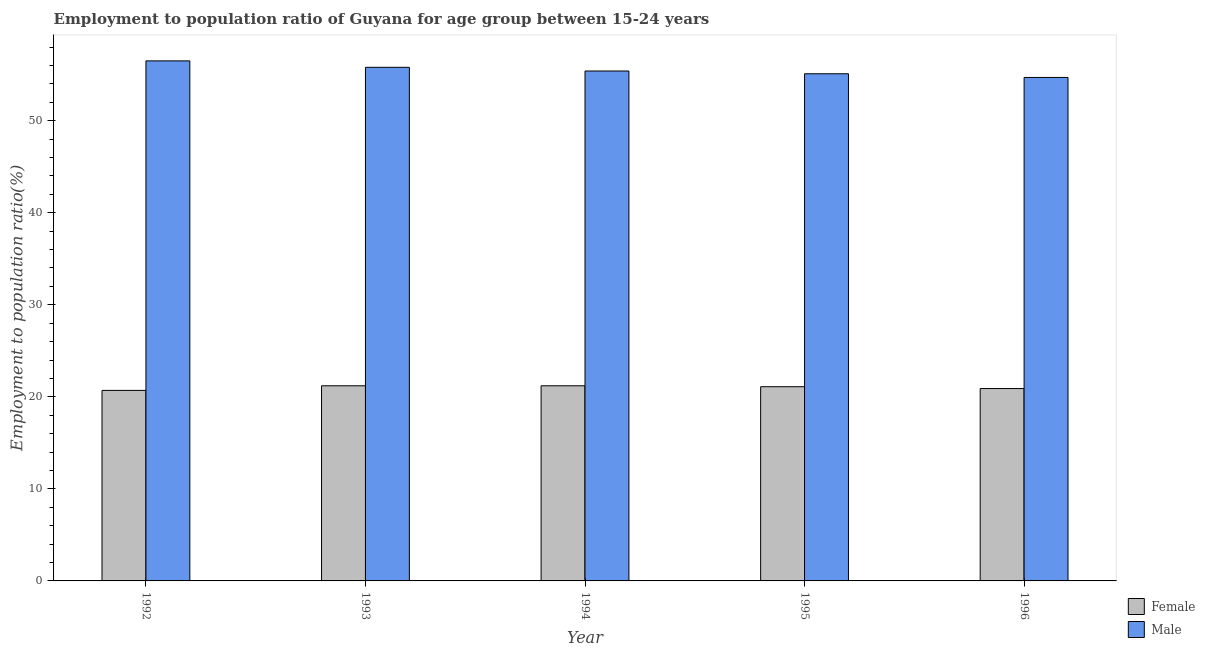How many groups of bars are there?
Your answer should be very brief. 5. Are the number of bars on each tick of the X-axis equal?
Ensure brevity in your answer.  Yes. How many bars are there on the 4th tick from the left?
Your answer should be compact. 2. What is the label of the 2nd group of bars from the left?
Offer a very short reply. 1993. In how many cases, is the number of bars for a given year not equal to the number of legend labels?
Provide a succinct answer. 0. What is the employment to population ratio(female) in 1996?
Your answer should be compact. 20.9. Across all years, what is the maximum employment to population ratio(male)?
Your response must be concise. 56.5. Across all years, what is the minimum employment to population ratio(male)?
Your answer should be compact. 54.7. What is the total employment to population ratio(female) in the graph?
Keep it short and to the point. 105.1. What is the difference between the employment to population ratio(male) in 1993 and that in 1995?
Your answer should be compact. 0.7. What is the difference between the employment to population ratio(female) in 1995 and the employment to population ratio(male) in 1992?
Your answer should be compact. 0.4. What is the average employment to population ratio(female) per year?
Your answer should be very brief. 21.02. In the year 1996, what is the difference between the employment to population ratio(female) and employment to population ratio(male)?
Make the answer very short. 0. In how many years, is the employment to population ratio(male) greater than 44 %?
Your response must be concise. 5. What is the ratio of the employment to population ratio(male) in 1992 to that in 1994?
Your response must be concise. 1.02. Is the difference between the employment to population ratio(female) in 1994 and 1996 greater than the difference between the employment to population ratio(male) in 1994 and 1996?
Make the answer very short. No. What is the difference between the highest and the second highest employment to population ratio(male)?
Your response must be concise. 0.7. What is the difference between the highest and the lowest employment to population ratio(male)?
Keep it short and to the point. 1.8. In how many years, is the employment to population ratio(female) greater than the average employment to population ratio(female) taken over all years?
Give a very brief answer. 3. What does the 1st bar from the right in 1992 represents?
Your answer should be compact. Male. How many bars are there?
Offer a terse response. 10. Does the graph contain grids?
Ensure brevity in your answer.  No. Where does the legend appear in the graph?
Your response must be concise. Bottom right. What is the title of the graph?
Make the answer very short. Employment to population ratio of Guyana for age group between 15-24 years. What is the label or title of the Y-axis?
Offer a terse response. Employment to population ratio(%). What is the Employment to population ratio(%) of Female in 1992?
Keep it short and to the point. 20.7. What is the Employment to population ratio(%) of Male in 1992?
Ensure brevity in your answer.  56.5. What is the Employment to population ratio(%) in Female in 1993?
Keep it short and to the point. 21.2. What is the Employment to population ratio(%) of Male in 1993?
Ensure brevity in your answer.  55.8. What is the Employment to population ratio(%) in Female in 1994?
Keep it short and to the point. 21.2. What is the Employment to population ratio(%) in Male in 1994?
Your answer should be very brief. 55.4. What is the Employment to population ratio(%) of Female in 1995?
Your answer should be very brief. 21.1. What is the Employment to population ratio(%) in Male in 1995?
Offer a terse response. 55.1. What is the Employment to population ratio(%) in Female in 1996?
Ensure brevity in your answer.  20.9. What is the Employment to population ratio(%) of Male in 1996?
Your answer should be compact. 54.7. Across all years, what is the maximum Employment to population ratio(%) of Female?
Your response must be concise. 21.2. Across all years, what is the maximum Employment to population ratio(%) in Male?
Give a very brief answer. 56.5. Across all years, what is the minimum Employment to population ratio(%) in Female?
Your answer should be very brief. 20.7. Across all years, what is the minimum Employment to population ratio(%) of Male?
Offer a very short reply. 54.7. What is the total Employment to population ratio(%) in Female in the graph?
Give a very brief answer. 105.1. What is the total Employment to population ratio(%) of Male in the graph?
Provide a succinct answer. 277.5. What is the difference between the Employment to population ratio(%) of Male in 1992 and that in 1995?
Make the answer very short. 1.4. What is the difference between the Employment to population ratio(%) of Male in 1992 and that in 1996?
Your answer should be compact. 1.8. What is the difference between the Employment to population ratio(%) in Female in 1993 and that in 1996?
Ensure brevity in your answer.  0.3. What is the difference between the Employment to population ratio(%) of Female in 1994 and that in 1995?
Give a very brief answer. 0.1. What is the difference between the Employment to population ratio(%) in Male in 1994 and that in 1995?
Your answer should be very brief. 0.3. What is the difference between the Employment to population ratio(%) in Female in 1995 and that in 1996?
Make the answer very short. 0.2. What is the difference between the Employment to population ratio(%) of Female in 1992 and the Employment to population ratio(%) of Male in 1993?
Give a very brief answer. -35.1. What is the difference between the Employment to population ratio(%) of Female in 1992 and the Employment to population ratio(%) of Male in 1994?
Your answer should be compact. -34.7. What is the difference between the Employment to population ratio(%) in Female in 1992 and the Employment to population ratio(%) in Male in 1995?
Your answer should be compact. -34.4. What is the difference between the Employment to population ratio(%) of Female in 1992 and the Employment to population ratio(%) of Male in 1996?
Keep it short and to the point. -34. What is the difference between the Employment to population ratio(%) in Female in 1993 and the Employment to population ratio(%) in Male in 1994?
Give a very brief answer. -34.2. What is the difference between the Employment to population ratio(%) in Female in 1993 and the Employment to population ratio(%) in Male in 1995?
Your response must be concise. -33.9. What is the difference between the Employment to population ratio(%) of Female in 1993 and the Employment to population ratio(%) of Male in 1996?
Ensure brevity in your answer.  -33.5. What is the difference between the Employment to population ratio(%) in Female in 1994 and the Employment to population ratio(%) in Male in 1995?
Offer a very short reply. -33.9. What is the difference between the Employment to population ratio(%) in Female in 1994 and the Employment to population ratio(%) in Male in 1996?
Your answer should be compact. -33.5. What is the difference between the Employment to population ratio(%) of Female in 1995 and the Employment to population ratio(%) of Male in 1996?
Offer a very short reply. -33.6. What is the average Employment to population ratio(%) in Female per year?
Offer a very short reply. 21.02. What is the average Employment to population ratio(%) of Male per year?
Provide a short and direct response. 55.5. In the year 1992, what is the difference between the Employment to population ratio(%) of Female and Employment to population ratio(%) of Male?
Make the answer very short. -35.8. In the year 1993, what is the difference between the Employment to population ratio(%) in Female and Employment to population ratio(%) in Male?
Offer a terse response. -34.6. In the year 1994, what is the difference between the Employment to population ratio(%) of Female and Employment to population ratio(%) of Male?
Give a very brief answer. -34.2. In the year 1995, what is the difference between the Employment to population ratio(%) in Female and Employment to population ratio(%) in Male?
Offer a terse response. -34. In the year 1996, what is the difference between the Employment to population ratio(%) in Female and Employment to population ratio(%) in Male?
Ensure brevity in your answer.  -33.8. What is the ratio of the Employment to population ratio(%) in Female in 1992 to that in 1993?
Ensure brevity in your answer.  0.98. What is the ratio of the Employment to population ratio(%) in Male in 1992 to that in 1993?
Make the answer very short. 1.01. What is the ratio of the Employment to population ratio(%) of Female in 1992 to that in 1994?
Offer a terse response. 0.98. What is the ratio of the Employment to population ratio(%) in Male in 1992 to that in 1994?
Your response must be concise. 1.02. What is the ratio of the Employment to population ratio(%) in Female in 1992 to that in 1995?
Offer a terse response. 0.98. What is the ratio of the Employment to population ratio(%) of Male in 1992 to that in 1995?
Give a very brief answer. 1.03. What is the ratio of the Employment to population ratio(%) of Female in 1992 to that in 1996?
Offer a very short reply. 0.99. What is the ratio of the Employment to population ratio(%) in Male in 1992 to that in 1996?
Your answer should be compact. 1.03. What is the ratio of the Employment to population ratio(%) of Female in 1993 to that in 1994?
Make the answer very short. 1. What is the ratio of the Employment to population ratio(%) in Male in 1993 to that in 1994?
Provide a short and direct response. 1.01. What is the ratio of the Employment to population ratio(%) of Male in 1993 to that in 1995?
Make the answer very short. 1.01. What is the ratio of the Employment to population ratio(%) of Female in 1993 to that in 1996?
Your answer should be compact. 1.01. What is the ratio of the Employment to population ratio(%) in Male in 1993 to that in 1996?
Keep it short and to the point. 1.02. What is the ratio of the Employment to population ratio(%) of Female in 1994 to that in 1995?
Make the answer very short. 1. What is the ratio of the Employment to population ratio(%) in Male in 1994 to that in 1995?
Ensure brevity in your answer.  1.01. What is the ratio of the Employment to population ratio(%) in Female in 1994 to that in 1996?
Give a very brief answer. 1.01. What is the ratio of the Employment to population ratio(%) of Male in 1994 to that in 1996?
Provide a succinct answer. 1.01. What is the ratio of the Employment to population ratio(%) in Female in 1995 to that in 1996?
Offer a very short reply. 1.01. What is the ratio of the Employment to population ratio(%) of Male in 1995 to that in 1996?
Give a very brief answer. 1.01. What is the difference between the highest and the second highest Employment to population ratio(%) in Female?
Ensure brevity in your answer.  0. What is the difference between the highest and the second highest Employment to population ratio(%) in Male?
Give a very brief answer. 0.7. What is the difference between the highest and the lowest Employment to population ratio(%) of Female?
Provide a succinct answer. 0.5. 